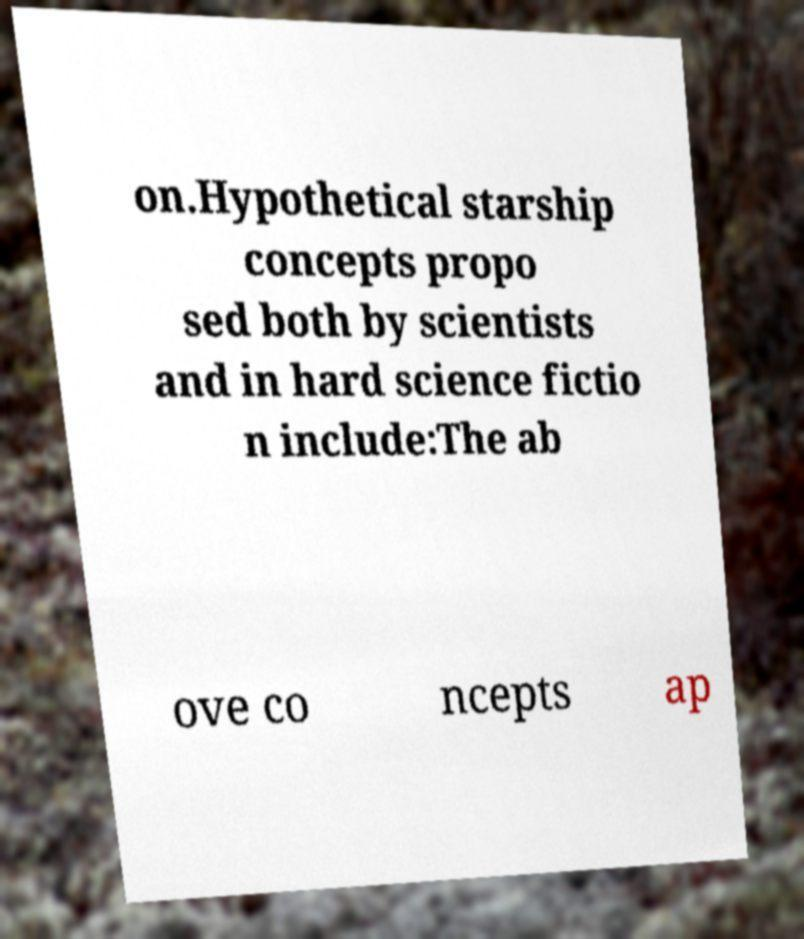Please read and relay the text visible in this image. What does it say? on.Hypothetical starship concepts propo sed both by scientists and in hard science fictio n include:The ab ove co ncepts ap 